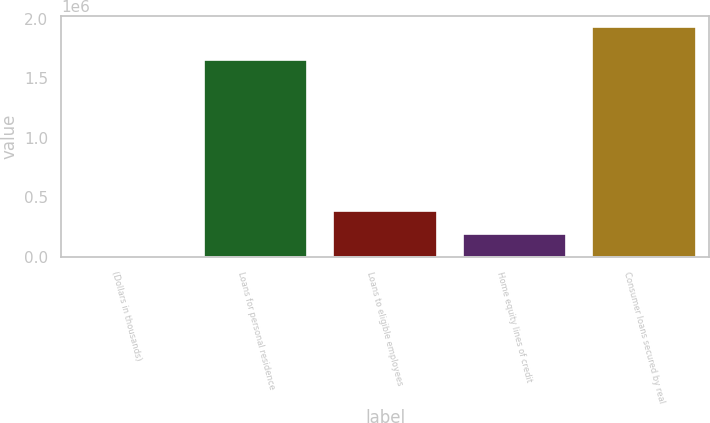Convert chart. <chart><loc_0><loc_0><loc_500><loc_500><bar_chart><fcel>(Dollars in thousands)<fcel>Loans for personal residence<fcel>Loans to eligible employees<fcel>Home equity lines of credit<fcel>Consumer loans secured by real<nl><fcel>2016<fcel>1.65535e+06<fcel>387006<fcel>194511<fcel>1.92697e+06<nl></chart> 